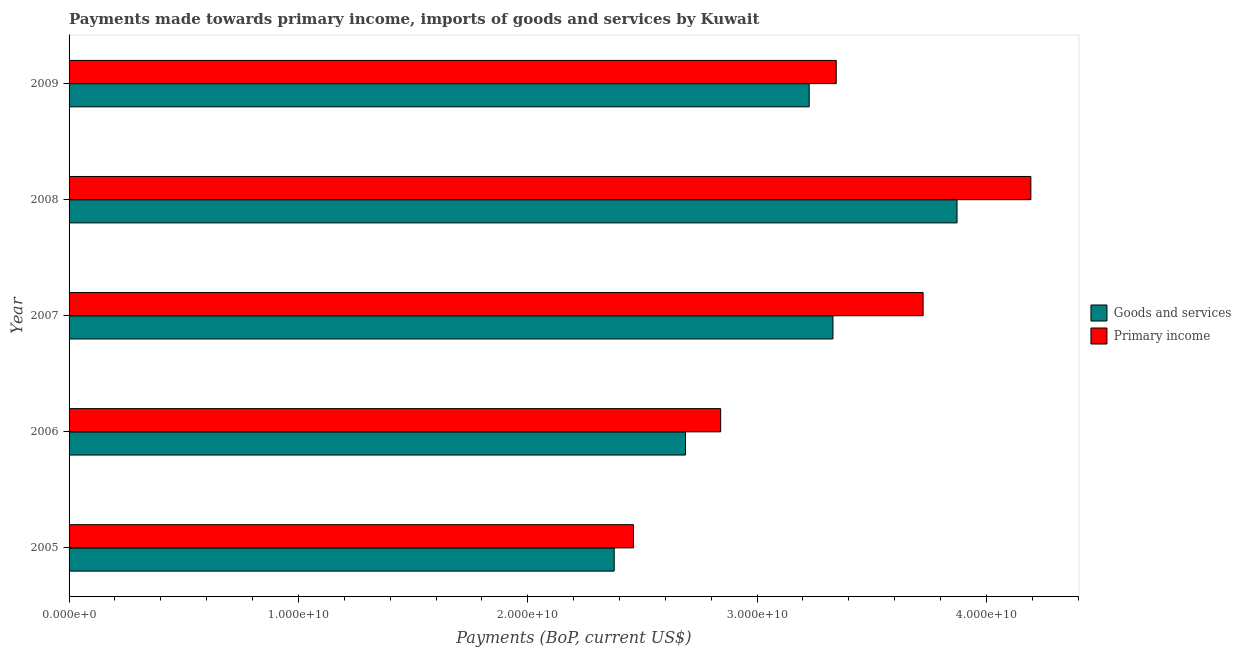How many different coloured bars are there?
Offer a terse response. 2. How many groups of bars are there?
Your response must be concise. 5. Are the number of bars per tick equal to the number of legend labels?
Make the answer very short. Yes. In how many cases, is the number of bars for a given year not equal to the number of legend labels?
Offer a terse response. 0. What is the payments made towards primary income in 2005?
Keep it short and to the point. 2.46e+1. Across all years, what is the maximum payments made towards primary income?
Provide a succinct answer. 4.19e+1. Across all years, what is the minimum payments made towards primary income?
Your response must be concise. 2.46e+1. In which year was the payments made towards primary income maximum?
Offer a very short reply. 2008. What is the total payments made towards goods and services in the graph?
Make the answer very short. 1.55e+11. What is the difference between the payments made towards primary income in 2005 and that in 2007?
Give a very brief answer. -1.26e+1. What is the difference between the payments made towards primary income in 2009 and the payments made towards goods and services in 2005?
Ensure brevity in your answer.  9.68e+09. What is the average payments made towards primary income per year?
Provide a succinct answer. 3.31e+1. In the year 2006, what is the difference between the payments made towards goods and services and payments made towards primary income?
Make the answer very short. -1.53e+09. In how many years, is the payments made towards primary income greater than 20000000000 US$?
Your answer should be very brief. 5. What is the ratio of the payments made towards goods and services in 2005 to that in 2008?
Offer a terse response. 0.61. Is the payments made towards goods and services in 2007 less than that in 2009?
Provide a short and direct response. No. Is the difference between the payments made towards primary income in 2007 and 2008 greater than the difference between the payments made towards goods and services in 2007 and 2008?
Offer a terse response. Yes. What is the difference between the highest and the second highest payments made towards primary income?
Keep it short and to the point. 4.70e+09. What is the difference between the highest and the lowest payments made towards goods and services?
Your answer should be compact. 1.49e+1. What does the 2nd bar from the top in 2007 represents?
Keep it short and to the point. Goods and services. What does the 1st bar from the bottom in 2006 represents?
Your response must be concise. Goods and services. How many bars are there?
Give a very brief answer. 10. Does the graph contain grids?
Make the answer very short. No. Where does the legend appear in the graph?
Provide a succinct answer. Center right. How are the legend labels stacked?
Your response must be concise. Vertical. What is the title of the graph?
Provide a succinct answer. Payments made towards primary income, imports of goods and services by Kuwait. Does "Nitrous oxide emissions" appear as one of the legend labels in the graph?
Offer a terse response. No. What is the label or title of the X-axis?
Your answer should be very brief. Payments (BoP, current US$). What is the Payments (BoP, current US$) of Goods and services in 2005?
Your answer should be very brief. 2.38e+1. What is the Payments (BoP, current US$) in Primary income in 2005?
Keep it short and to the point. 2.46e+1. What is the Payments (BoP, current US$) of Goods and services in 2006?
Offer a very short reply. 2.69e+1. What is the Payments (BoP, current US$) of Primary income in 2006?
Your answer should be very brief. 2.84e+1. What is the Payments (BoP, current US$) in Goods and services in 2007?
Provide a short and direct response. 3.33e+1. What is the Payments (BoP, current US$) in Primary income in 2007?
Provide a short and direct response. 3.72e+1. What is the Payments (BoP, current US$) of Goods and services in 2008?
Your response must be concise. 3.87e+1. What is the Payments (BoP, current US$) of Primary income in 2008?
Your response must be concise. 4.19e+1. What is the Payments (BoP, current US$) in Goods and services in 2009?
Offer a terse response. 3.23e+1. What is the Payments (BoP, current US$) of Primary income in 2009?
Ensure brevity in your answer.  3.34e+1. Across all years, what is the maximum Payments (BoP, current US$) of Goods and services?
Give a very brief answer. 3.87e+1. Across all years, what is the maximum Payments (BoP, current US$) in Primary income?
Provide a succinct answer. 4.19e+1. Across all years, what is the minimum Payments (BoP, current US$) of Goods and services?
Offer a very short reply. 2.38e+1. Across all years, what is the minimum Payments (BoP, current US$) in Primary income?
Ensure brevity in your answer.  2.46e+1. What is the total Payments (BoP, current US$) of Goods and services in the graph?
Your answer should be very brief. 1.55e+11. What is the total Payments (BoP, current US$) of Primary income in the graph?
Provide a short and direct response. 1.66e+11. What is the difference between the Payments (BoP, current US$) of Goods and services in 2005 and that in 2006?
Ensure brevity in your answer.  -3.11e+09. What is the difference between the Payments (BoP, current US$) in Primary income in 2005 and that in 2006?
Your answer should be very brief. -3.80e+09. What is the difference between the Payments (BoP, current US$) of Goods and services in 2005 and that in 2007?
Ensure brevity in your answer.  -9.54e+09. What is the difference between the Payments (BoP, current US$) of Primary income in 2005 and that in 2007?
Offer a terse response. -1.26e+1. What is the difference between the Payments (BoP, current US$) of Goods and services in 2005 and that in 2008?
Offer a very short reply. -1.49e+1. What is the difference between the Payments (BoP, current US$) of Primary income in 2005 and that in 2008?
Offer a terse response. -1.73e+1. What is the difference between the Payments (BoP, current US$) of Goods and services in 2005 and that in 2009?
Give a very brief answer. -8.50e+09. What is the difference between the Payments (BoP, current US$) in Primary income in 2005 and that in 2009?
Offer a terse response. -8.84e+09. What is the difference between the Payments (BoP, current US$) in Goods and services in 2006 and that in 2007?
Provide a short and direct response. -6.43e+09. What is the difference between the Payments (BoP, current US$) of Primary income in 2006 and that in 2007?
Offer a very short reply. -8.83e+09. What is the difference between the Payments (BoP, current US$) in Goods and services in 2006 and that in 2008?
Make the answer very short. -1.18e+1. What is the difference between the Payments (BoP, current US$) in Primary income in 2006 and that in 2008?
Give a very brief answer. -1.35e+1. What is the difference between the Payments (BoP, current US$) of Goods and services in 2006 and that in 2009?
Your response must be concise. -5.39e+09. What is the difference between the Payments (BoP, current US$) in Primary income in 2006 and that in 2009?
Your response must be concise. -5.04e+09. What is the difference between the Payments (BoP, current US$) of Goods and services in 2007 and that in 2008?
Your response must be concise. -5.41e+09. What is the difference between the Payments (BoP, current US$) in Primary income in 2007 and that in 2008?
Your answer should be compact. -4.70e+09. What is the difference between the Payments (BoP, current US$) in Goods and services in 2007 and that in 2009?
Your answer should be compact. 1.03e+09. What is the difference between the Payments (BoP, current US$) in Primary income in 2007 and that in 2009?
Offer a very short reply. 3.79e+09. What is the difference between the Payments (BoP, current US$) in Goods and services in 2008 and that in 2009?
Make the answer very short. 6.45e+09. What is the difference between the Payments (BoP, current US$) in Primary income in 2008 and that in 2009?
Make the answer very short. 8.49e+09. What is the difference between the Payments (BoP, current US$) in Goods and services in 2005 and the Payments (BoP, current US$) in Primary income in 2006?
Give a very brief answer. -4.64e+09. What is the difference between the Payments (BoP, current US$) of Goods and services in 2005 and the Payments (BoP, current US$) of Primary income in 2007?
Keep it short and to the point. -1.35e+1. What is the difference between the Payments (BoP, current US$) in Goods and services in 2005 and the Payments (BoP, current US$) in Primary income in 2008?
Your answer should be very brief. -1.82e+1. What is the difference between the Payments (BoP, current US$) in Goods and services in 2005 and the Payments (BoP, current US$) in Primary income in 2009?
Keep it short and to the point. -9.68e+09. What is the difference between the Payments (BoP, current US$) of Goods and services in 2006 and the Payments (BoP, current US$) of Primary income in 2007?
Your answer should be compact. -1.04e+1. What is the difference between the Payments (BoP, current US$) of Goods and services in 2006 and the Payments (BoP, current US$) of Primary income in 2008?
Offer a very short reply. -1.51e+1. What is the difference between the Payments (BoP, current US$) in Goods and services in 2006 and the Payments (BoP, current US$) in Primary income in 2009?
Offer a terse response. -6.57e+09. What is the difference between the Payments (BoP, current US$) of Goods and services in 2007 and the Payments (BoP, current US$) of Primary income in 2008?
Make the answer very short. -8.63e+09. What is the difference between the Payments (BoP, current US$) of Goods and services in 2007 and the Payments (BoP, current US$) of Primary income in 2009?
Offer a very short reply. -1.44e+08. What is the difference between the Payments (BoP, current US$) of Goods and services in 2008 and the Payments (BoP, current US$) of Primary income in 2009?
Your answer should be compact. 5.27e+09. What is the average Payments (BoP, current US$) in Goods and services per year?
Offer a terse response. 3.10e+1. What is the average Payments (BoP, current US$) in Primary income per year?
Keep it short and to the point. 3.31e+1. In the year 2005, what is the difference between the Payments (BoP, current US$) of Goods and services and Payments (BoP, current US$) of Primary income?
Offer a very short reply. -8.41e+08. In the year 2006, what is the difference between the Payments (BoP, current US$) of Goods and services and Payments (BoP, current US$) of Primary income?
Provide a short and direct response. -1.53e+09. In the year 2007, what is the difference between the Payments (BoP, current US$) of Goods and services and Payments (BoP, current US$) of Primary income?
Your answer should be compact. -3.93e+09. In the year 2008, what is the difference between the Payments (BoP, current US$) in Goods and services and Payments (BoP, current US$) in Primary income?
Keep it short and to the point. -3.22e+09. In the year 2009, what is the difference between the Payments (BoP, current US$) in Goods and services and Payments (BoP, current US$) in Primary income?
Provide a short and direct response. -1.18e+09. What is the ratio of the Payments (BoP, current US$) of Goods and services in 2005 to that in 2006?
Ensure brevity in your answer.  0.88. What is the ratio of the Payments (BoP, current US$) in Primary income in 2005 to that in 2006?
Your answer should be very brief. 0.87. What is the ratio of the Payments (BoP, current US$) in Goods and services in 2005 to that in 2007?
Keep it short and to the point. 0.71. What is the ratio of the Payments (BoP, current US$) of Primary income in 2005 to that in 2007?
Keep it short and to the point. 0.66. What is the ratio of the Payments (BoP, current US$) in Goods and services in 2005 to that in 2008?
Provide a succinct answer. 0.61. What is the ratio of the Payments (BoP, current US$) of Primary income in 2005 to that in 2008?
Make the answer very short. 0.59. What is the ratio of the Payments (BoP, current US$) in Goods and services in 2005 to that in 2009?
Your answer should be very brief. 0.74. What is the ratio of the Payments (BoP, current US$) in Primary income in 2005 to that in 2009?
Your answer should be very brief. 0.74. What is the ratio of the Payments (BoP, current US$) in Goods and services in 2006 to that in 2007?
Provide a succinct answer. 0.81. What is the ratio of the Payments (BoP, current US$) of Primary income in 2006 to that in 2007?
Offer a terse response. 0.76. What is the ratio of the Payments (BoP, current US$) in Goods and services in 2006 to that in 2008?
Provide a succinct answer. 0.69. What is the ratio of the Payments (BoP, current US$) in Primary income in 2006 to that in 2008?
Give a very brief answer. 0.68. What is the ratio of the Payments (BoP, current US$) in Goods and services in 2006 to that in 2009?
Make the answer very short. 0.83. What is the ratio of the Payments (BoP, current US$) of Primary income in 2006 to that in 2009?
Your answer should be very brief. 0.85. What is the ratio of the Payments (BoP, current US$) of Goods and services in 2007 to that in 2008?
Offer a terse response. 0.86. What is the ratio of the Payments (BoP, current US$) in Primary income in 2007 to that in 2008?
Your answer should be compact. 0.89. What is the ratio of the Payments (BoP, current US$) of Goods and services in 2007 to that in 2009?
Ensure brevity in your answer.  1.03. What is the ratio of the Payments (BoP, current US$) in Primary income in 2007 to that in 2009?
Your answer should be compact. 1.11. What is the ratio of the Payments (BoP, current US$) of Goods and services in 2008 to that in 2009?
Keep it short and to the point. 1.2. What is the ratio of the Payments (BoP, current US$) of Primary income in 2008 to that in 2009?
Your response must be concise. 1.25. What is the difference between the highest and the second highest Payments (BoP, current US$) in Goods and services?
Offer a terse response. 5.41e+09. What is the difference between the highest and the second highest Payments (BoP, current US$) in Primary income?
Your answer should be compact. 4.70e+09. What is the difference between the highest and the lowest Payments (BoP, current US$) in Goods and services?
Your answer should be very brief. 1.49e+1. What is the difference between the highest and the lowest Payments (BoP, current US$) in Primary income?
Provide a succinct answer. 1.73e+1. 